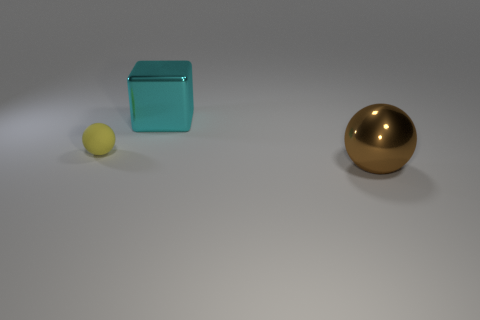Are there any other things that are the same shape as the large cyan thing?
Your response must be concise. No. There is a big thing that is to the left of the big thing that is in front of the large metal thing behind the large brown ball; what shape is it?
Your response must be concise. Cube. What is the shape of the large cyan object?
Your answer should be very brief. Cube. The large object that is right of the block is what color?
Your answer should be very brief. Brown. There is a ball that is right of the cyan metal cube; is it the same size as the tiny yellow matte thing?
Offer a very short reply. No. What is the size of the other thing that is the same shape as the large brown object?
Make the answer very short. Small. Is there anything else that has the same size as the brown sphere?
Your answer should be very brief. Yes. Is the rubber object the same shape as the cyan object?
Provide a succinct answer. No. Is the number of rubber balls behind the large cyan cube less than the number of large cyan metallic things that are in front of the large metal ball?
Make the answer very short. No. There is a tiny rubber object; how many large brown metallic objects are behind it?
Your answer should be very brief. 0. 